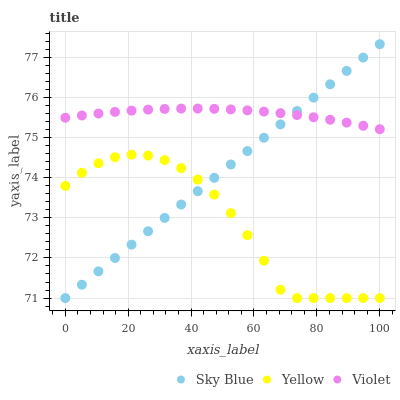Does Yellow have the minimum area under the curve?
Answer yes or no. Yes. Does Violet have the maximum area under the curve?
Answer yes or no. Yes. Does Violet have the minimum area under the curve?
Answer yes or no. No. Does Yellow have the maximum area under the curve?
Answer yes or no. No. Is Sky Blue the smoothest?
Answer yes or no. Yes. Is Yellow the roughest?
Answer yes or no. Yes. Is Violet the smoothest?
Answer yes or no. No. Is Violet the roughest?
Answer yes or no. No. Does Sky Blue have the lowest value?
Answer yes or no. Yes. Does Violet have the lowest value?
Answer yes or no. No. Does Sky Blue have the highest value?
Answer yes or no. Yes. Does Violet have the highest value?
Answer yes or no. No. Is Yellow less than Violet?
Answer yes or no. Yes. Is Violet greater than Yellow?
Answer yes or no. Yes. Does Sky Blue intersect Yellow?
Answer yes or no. Yes. Is Sky Blue less than Yellow?
Answer yes or no. No. Is Sky Blue greater than Yellow?
Answer yes or no. No. Does Yellow intersect Violet?
Answer yes or no. No. 